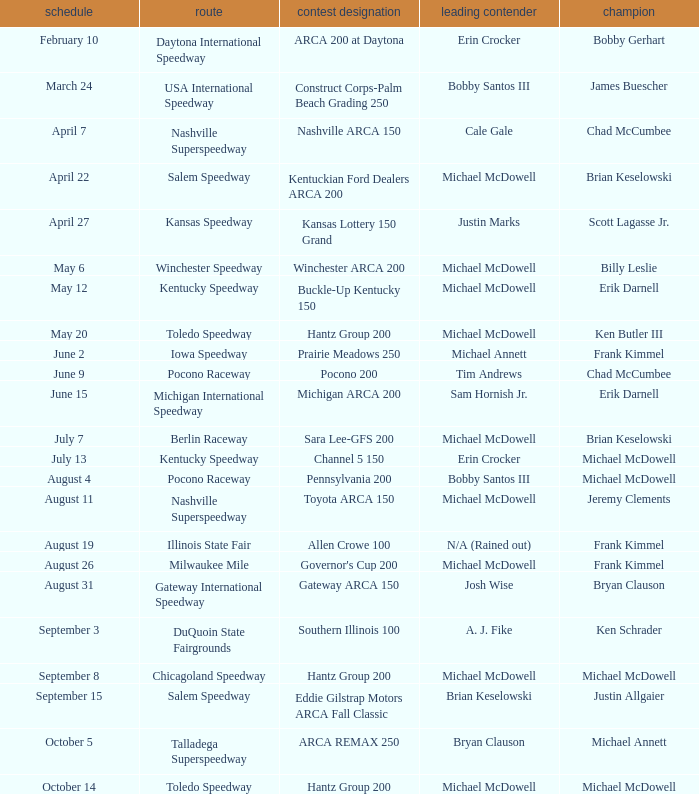Could you help me parse every detail presented in this table? {'header': ['schedule', 'route', 'contest designation', 'leading contender', 'champion'], 'rows': [['February 10', 'Daytona International Speedway', 'ARCA 200 at Daytona', 'Erin Crocker', 'Bobby Gerhart'], ['March 24', 'USA International Speedway', 'Construct Corps-Palm Beach Grading 250', 'Bobby Santos III', 'James Buescher'], ['April 7', 'Nashville Superspeedway', 'Nashville ARCA 150', 'Cale Gale', 'Chad McCumbee'], ['April 22', 'Salem Speedway', 'Kentuckian Ford Dealers ARCA 200', 'Michael McDowell', 'Brian Keselowski'], ['April 27', 'Kansas Speedway', 'Kansas Lottery 150 Grand', 'Justin Marks', 'Scott Lagasse Jr.'], ['May 6', 'Winchester Speedway', 'Winchester ARCA 200', 'Michael McDowell', 'Billy Leslie'], ['May 12', 'Kentucky Speedway', 'Buckle-Up Kentucky 150', 'Michael McDowell', 'Erik Darnell'], ['May 20', 'Toledo Speedway', 'Hantz Group 200', 'Michael McDowell', 'Ken Butler III'], ['June 2', 'Iowa Speedway', 'Prairie Meadows 250', 'Michael Annett', 'Frank Kimmel'], ['June 9', 'Pocono Raceway', 'Pocono 200', 'Tim Andrews', 'Chad McCumbee'], ['June 15', 'Michigan International Speedway', 'Michigan ARCA 200', 'Sam Hornish Jr.', 'Erik Darnell'], ['July 7', 'Berlin Raceway', 'Sara Lee-GFS 200', 'Michael McDowell', 'Brian Keselowski'], ['July 13', 'Kentucky Speedway', 'Channel 5 150', 'Erin Crocker', 'Michael McDowell'], ['August 4', 'Pocono Raceway', 'Pennsylvania 200', 'Bobby Santos III', 'Michael McDowell'], ['August 11', 'Nashville Superspeedway', 'Toyota ARCA 150', 'Michael McDowell', 'Jeremy Clements'], ['August 19', 'Illinois State Fair', 'Allen Crowe 100', 'N/A (Rained out)', 'Frank Kimmel'], ['August 26', 'Milwaukee Mile', "Governor's Cup 200", 'Michael McDowell', 'Frank Kimmel'], ['August 31', 'Gateway International Speedway', 'Gateway ARCA 150', 'Josh Wise', 'Bryan Clauson'], ['September 3', 'DuQuoin State Fairgrounds', 'Southern Illinois 100', 'A. J. Fike', 'Ken Schrader'], ['September 8', 'Chicagoland Speedway', 'Hantz Group 200', 'Michael McDowell', 'Michael McDowell'], ['September 15', 'Salem Speedway', 'Eddie Gilstrap Motors ARCA Fall Classic', 'Brian Keselowski', 'Justin Allgaier'], ['October 5', 'Talladega Superspeedway', 'ARCA REMAX 250', 'Bryan Clauson', 'Michael Annett'], ['October 14', 'Toledo Speedway', 'Hantz Group 200', 'Michael McDowell', 'Michael McDowell']]} Tell me the track for june 9 Pocono Raceway. 